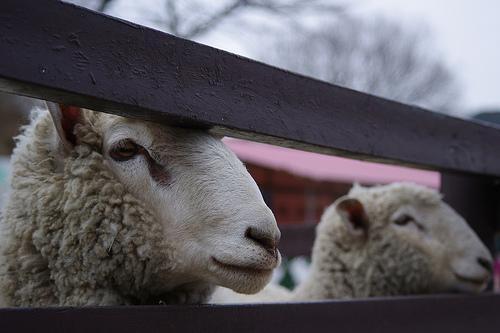How many animals are there?
Give a very brief answer. 2. 